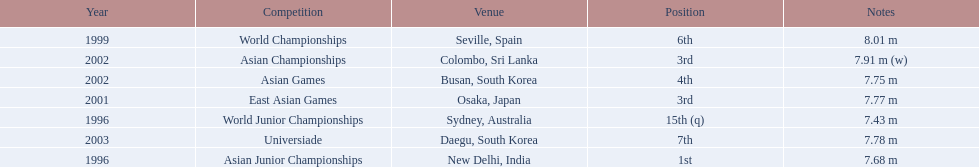What competitions did huang le compete in? World Junior Championships, Asian Junior Championships, World Championships, East Asian Games, Asian Championships, Asian Games, Universiade. What distances did he achieve in these competitions? 7.43 m, 7.68 m, 8.01 m, 7.77 m, 7.91 m (w), 7.75 m, 7.78 m. Which of these distances was the longest? 7.91 m (w). 